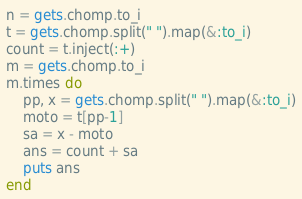Convert code to text. <code><loc_0><loc_0><loc_500><loc_500><_Ruby_>n = gets.chomp.to_i
t = gets.chomp.split(" ").map(&:to_i)
count = t.inject(:+)
m = gets.chomp.to_i
m.times do
    pp, x = gets.chomp.split(" ").map(&:to_i)
    moto = t[pp-1]
    sa = x - moto
    ans = count + sa
    puts ans
end</code> 